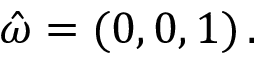<formula> <loc_0><loc_0><loc_500><loc_500>\hat { \omega } = ( 0 , 0 , 1 ) \, .</formula> 